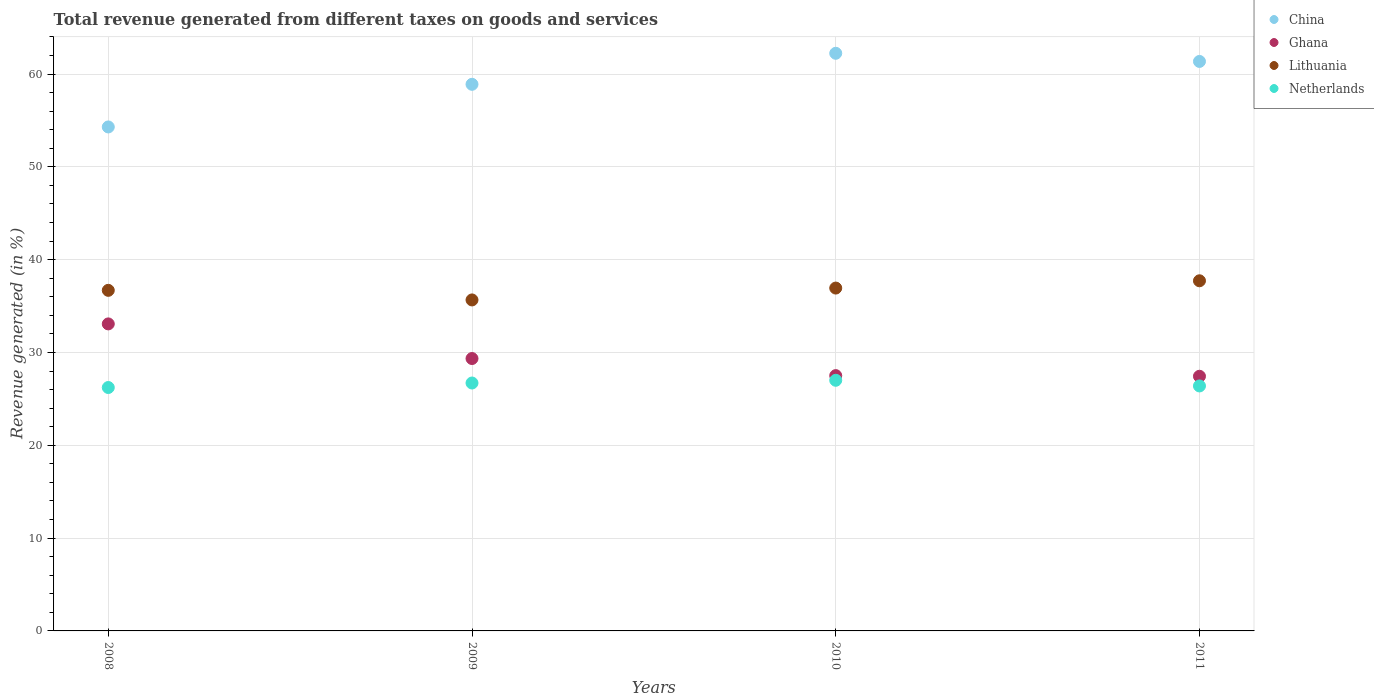How many different coloured dotlines are there?
Your answer should be very brief. 4. Is the number of dotlines equal to the number of legend labels?
Provide a short and direct response. Yes. What is the total revenue generated in China in 2008?
Ensure brevity in your answer.  54.3. Across all years, what is the maximum total revenue generated in Lithuania?
Your answer should be very brief. 37.72. Across all years, what is the minimum total revenue generated in Ghana?
Make the answer very short. 27.44. In which year was the total revenue generated in China minimum?
Make the answer very short. 2008. What is the total total revenue generated in Ghana in the graph?
Your response must be concise. 117.37. What is the difference between the total revenue generated in Netherlands in 2008 and that in 2011?
Your answer should be compact. -0.17. What is the difference between the total revenue generated in China in 2011 and the total revenue generated in Ghana in 2009?
Offer a very short reply. 32.01. What is the average total revenue generated in Netherlands per year?
Your answer should be compact. 26.58. In the year 2008, what is the difference between the total revenue generated in Netherlands and total revenue generated in China?
Your answer should be very brief. -28.07. What is the ratio of the total revenue generated in China in 2010 to that in 2011?
Provide a succinct answer. 1.01. Is the total revenue generated in Ghana in 2008 less than that in 2009?
Give a very brief answer. No. Is the difference between the total revenue generated in Netherlands in 2009 and 2011 greater than the difference between the total revenue generated in China in 2009 and 2011?
Offer a terse response. Yes. What is the difference between the highest and the second highest total revenue generated in Ghana?
Provide a short and direct response. 3.73. What is the difference between the highest and the lowest total revenue generated in Ghana?
Make the answer very short. 5.64. In how many years, is the total revenue generated in China greater than the average total revenue generated in China taken over all years?
Your answer should be very brief. 2. Is it the case that in every year, the sum of the total revenue generated in Lithuania and total revenue generated in Netherlands  is greater than the sum of total revenue generated in China and total revenue generated in Ghana?
Make the answer very short. No. Does the total revenue generated in Lithuania monotonically increase over the years?
Ensure brevity in your answer.  No. How many years are there in the graph?
Your answer should be very brief. 4. Does the graph contain any zero values?
Offer a terse response. No. How many legend labels are there?
Your response must be concise. 4. What is the title of the graph?
Provide a short and direct response. Total revenue generated from different taxes on goods and services. What is the label or title of the X-axis?
Provide a succinct answer. Years. What is the label or title of the Y-axis?
Your response must be concise. Revenue generated (in %). What is the Revenue generated (in %) of China in 2008?
Offer a terse response. 54.3. What is the Revenue generated (in %) of Ghana in 2008?
Ensure brevity in your answer.  33.08. What is the Revenue generated (in %) of Lithuania in 2008?
Your answer should be very brief. 36.69. What is the Revenue generated (in %) in Netherlands in 2008?
Your answer should be compact. 26.22. What is the Revenue generated (in %) in China in 2009?
Provide a short and direct response. 58.89. What is the Revenue generated (in %) in Ghana in 2009?
Your answer should be very brief. 29.35. What is the Revenue generated (in %) of Lithuania in 2009?
Make the answer very short. 35.66. What is the Revenue generated (in %) in Netherlands in 2009?
Provide a short and direct response. 26.71. What is the Revenue generated (in %) in China in 2010?
Your response must be concise. 62.23. What is the Revenue generated (in %) of Ghana in 2010?
Provide a short and direct response. 27.51. What is the Revenue generated (in %) of Lithuania in 2010?
Provide a short and direct response. 36.94. What is the Revenue generated (in %) in Netherlands in 2010?
Ensure brevity in your answer.  27. What is the Revenue generated (in %) in China in 2011?
Give a very brief answer. 61.36. What is the Revenue generated (in %) of Ghana in 2011?
Your answer should be compact. 27.44. What is the Revenue generated (in %) in Lithuania in 2011?
Your response must be concise. 37.72. What is the Revenue generated (in %) in Netherlands in 2011?
Give a very brief answer. 26.39. Across all years, what is the maximum Revenue generated (in %) of China?
Give a very brief answer. 62.23. Across all years, what is the maximum Revenue generated (in %) in Ghana?
Your response must be concise. 33.08. Across all years, what is the maximum Revenue generated (in %) of Lithuania?
Keep it short and to the point. 37.72. Across all years, what is the maximum Revenue generated (in %) in Netherlands?
Provide a succinct answer. 27. Across all years, what is the minimum Revenue generated (in %) in China?
Your answer should be compact. 54.3. Across all years, what is the minimum Revenue generated (in %) in Ghana?
Provide a short and direct response. 27.44. Across all years, what is the minimum Revenue generated (in %) in Lithuania?
Offer a very short reply. 35.66. Across all years, what is the minimum Revenue generated (in %) of Netherlands?
Offer a very short reply. 26.22. What is the total Revenue generated (in %) in China in the graph?
Give a very brief answer. 236.78. What is the total Revenue generated (in %) in Ghana in the graph?
Your answer should be compact. 117.37. What is the total Revenue generated (in %) in Lithuania in the graph?
Provide a short and direct response. 147.02. What is the total Revenue generated (in %) in Netherlands in the graph?
Your response must be concise. 106.33. What is the difference between the Revenue generated (in %) in China in 2008 and that in 2009?
Provide a short and direct response. -4.59. What is the difference between the Revenue generated (in %) in Ghana in 2008 and that in 2009?
Your response must be concise. 3.73. What is the difference between the Revenue generated (in %) in Lithuania in 2008 and that in 2009?
Ensure brevity in your answer.  1.03. What is the difference between the Revenue generated (in %) of Netherlands in 2008 and that in 2009?
Give a very brief answer. -0.49. What is the difference between the Revenue generated (in %) in China in 2008 and that in 2010?
Keep it short and to the point. -7.94. What is the difference between the Revenue generated (in %) in Ghana in 2008 and that in 2010?
Your response must be concise. 5.57. What is the difference between the Revenue generated (in %) of Lithuania in 2008 and that in 2010?
Your answer should be compact. -0.24. What is the difference between the Revenue generated (in %) in Netherlands in 2008 and that in 2010?
Your answer should be compact. -0.78. What is the difference between the Revenue generated (in %) of China in 2008 and that in 2011?
Offer a terse response. -7.06. What is the difference between the Revenue generated (in %) of Ghana in 2008 and that in 2011?
Provide a short and direct response. 5.64. What is the difference between the Revenue generated (in %) in Lithuania in 2008 and that in 2011?
Give a very brief answer. -1.03. What is the difference between the Revenue generated (in %) of Netherlands in 2008 and that in 2011?
Your answer should be compact. -0.17. What is the difference between the Revenue generated (in %) of China in 2009 and that in 2010?
Make the answer very short. -3.34. What is the difference between the Revenue generated (in %) of Ghana in 2009 and that in 2010?
Offer a terse response. 1.84. What is the difference between the Revenue generated (in %) of Lithuania in 2009 and that in 2010?
Give a very brief answer. -1.28. What is the difference between the Revenue generated (in %) of Netherlands in 2009 and that in 2010?
Ensure brevity in your answer.  -0.29. What is the difference between the Revenue generated (in %) in China in 2009 and that in 2011?
Your answer should be compact. -2.46. What is the difference between the Revenue generated (in %) of Ghana in 2009 and that in 2011?
Provide a succinct answer. 1.91. What is the difference between the Revenue generated (in %) in Lithuania in 2009 and that in 2011?
Your answer should be very brief. -2.06. What is the difference between the Revenue generated (in %) of Netherlands in 2009 and that in 2011?
Your answer should be very brief. 0.32. What is the difference between the Revenue generated (in %) in China in 2010 and that in 2011?
Your response must be concise. 0.88. What is the difference between the Revenue generated (in %) in Ghana in 2010 and that in 2011?
Offer a very short reply. 0.07. What is the difference between the Revenue generated (in %) of Lithuania in 2010 and that in 2011?
Your answer should be very brief. -0.78. What is the difference between the Revenue generated (in %) in Netherlands in 2010 and that in 2011?
Your response must be concise. 0.61. What is the difference between the Revenue generated (in %) of China in 2008 and the Revenue generated (in %) of Ghana in 2009?
Make the answer very short. 24.95. What is the difference between the Revenue generated (in %) in China in 2008 and the Revenue generated (in %) in Lithuania in 2009?
Give a very brief answer. 18.64. What is the difference between the Revenue generated (in %) of China in 2008 and the Revenue generated (in %) of Netherlands in 2009?
Offer a very short reply. 27.59. What is the difference between the Revenue generated (in %) of Ghana in 2008 and the Revenue generated (in %) of Lithuania in 2009?
Give a very brief answer. -2.58. What is the difference between the Revenue generated (in %) of Ghana in 2008 and the Revenue generated (in %) of Netherlands in 2009?
Your answer should be compact. 6.37. What is the difference between the Revenue generated (in %) in Lithuania in 2008 and the Revenue generated (in %) in Netherlands in 2009?
Offer a terse response. 9.98. What is the difference between the Revenue generated (in %) in China in 2008 and the Revenue generated (in %) in Ghana in 2010?
Offer a very short reply. 26.79. What is the difference between the Revenue generated (in %) in China in 2008 and the Revenue generated (in %) in Lithuania in 2010?
Your response must be concise. 17.36. What is the difference between the Revenue generated (in %) in China in 2008 and the Revenue generated (in %) in Netherlands in 2010?
Provide a succinct answer. 27.29. What is the difference between the Revenue generated (in %) in Ghana in 2008 and the Revenue generated (in %) in Lithuania in 2010?
Your answer should be compact. -3.86. What is the difference between the Revenue generated (in %) in Ghana in 2008 and the Revenue generated (in %) in Netherlands in 2010?
Ensure brevity in your answer.  6.07. What is the difference between the Revenue generated (in %) in Lithuania in 2008 and the Revenue generated (in %) in Netherlands in 2010?
Your response must be concise. 9.69. What is the difference between the Revenue generated (in %) in China in 2008 and the Revenue generated (in %) in Ghana in 2011?
Provide a short and direct response. 26.86. What is the difference between the Revenue generated (in %) of China in 2008 and the Revenue generated (in %) of Lithuania in 2011?
Offer a very short reply. 16.57. What is the difference between the Revenue generated (in %) in China in 2008 and the Revenue generated (in %) in Netherlands in 2011?
Your answer should be compact. 27.9. What is the difference between the Revenue generated (in %) in Ghana in 2008 and the Revenue generated (in %) in Lithuania in 2011?
Offer a very short reply. -4.65. What is the difference between the Revenue generated (in %) of Ghana in 2008 and the Revenue generated (in %) of Netherlands in 2011?
Offer a very short reply. 6.68. What is the difference between the Revenue generated (in %) in Lithuania in 2008 and the Revenue generated (in %) in Netherlands in 2011?
Your answer should be compact. 10.3. What is the difference between the Revenue generated (in %) of China in 2009 and the Revenue generated (in %) of Ghana in 2010?
Your answer should be very brief. 31.39. What is the difference between the Revenue generated (in %) of China in 2009 and the Revenue generated (in %) of Lithuania in 2010?
Give a very brief answer. 21.95. What is the difference between the Revenue generated (in %) of China in 2009 and the Revenue generated (in %) of Netherlands in 2010?
Offer a very short reply. 31.89. What is the difference between the Revenue generated (in %) of Ghana in 2009 and the Revenue generated (in %) of Lithuania in 2010?
Your answer should be very brief. -7.59. What is the difference between the Revenue generated (in %) of Ghana in 2009 and the Revenue generated (in %) of Netherlands in 2010?
Your answer should be compact. 2.34. What is the difference between the Revenue generated (in %) of Lithuania in 2009 and the Revenue generated (in %) of Netherlands in 2010?
Provide a succinct answer. 8.66. What is the difference between the Revenue generated (in %) in China in 2009 and the Revenue generated (in %) in Ghana in 2011?
Provide a succinct answer. 31.46. What is the difference between the Revenue generated (in %) of China in 2009 and the Revenue generated (in %) of Lithuania in 2011?
Your answer should be compact. 21.17. What is the difference between the Revenue generated (in %) of China in 2009 and the Revenue generated (in %) of Netherlands in 2011?
Offer a very short reply. 32.5. What is the difference between the Revenue generated (in %) of Ghana in 2009 and the Revenue generated (in %) of Lithuania in 2011?
Your answer should be compact. -8.38. What is the difference between the Revenue generated (in %) in Ghana in 2009 and the Revenue generated (in %) in Netherlands in 2011?
Keep it short and to the point. 2.95. What is the difference between the Revenue generated (in %) in Lithuania in 2009 and the Revenue generated (in %) in Netherlands in 2011?
Your response must be concise. 9.27. What is the difference between the Revenue generated (in %) in China in 2010 and the Revenue generated (in %) in Ghana in 2011?
Your answer should be very brief. 34.8. What is the difference between the Revenue generated (in %) of China in 2010 and the Revenue generated (in %) of Lithuania in 2011?
Provide a short and direct response. 24.51. What is the difference between the Revenue generated (in %) of China in 2010 and the Revenue generated (in %) of Netherlands in 2011?
Your answer should be very brief. 35.84. What is the difference between the Revenue generated (in %) of Ghana in 2010 and the Revenue generated (in %) of Lithuania in 2011?
Make the answer very short. -10.22. What is the difference between the Revenue generated (in %) of Ghana in 2010 and the Revenue generated (in %) of Netherlands in 2011?
Your response must be concise. 1.11. What is the difference between the Revenue generated (in %) of Lithuania in 2010 and the Revenue generated (in %) of Netherlands in 2011?
Give a very brief answer. 10.54. What is the average Revenue generated (in %) of China per year?
Ensure brevity in your answer.  59.2. What is the average Revenue generated (in %) in Ghana per year?
Offer a terse response. 29.34. What is the average Revenue generated (in %) in Lithuania per year?
Your response must be concise. 36.75. What is the average Revenue generated (in %) of Netherlands per year?
Ensure brevity in your answer.  26.58. In the year 2008, what is the difference between the Revenue generated (in %) of China and Revenue generated (in %) of Ghana?
Your answer should be compact. 21.22. In the year 2008, what is the difference between the Revenue generated (in %) of China and Revenue generated (in %) of Lithuania?
Offer a terse response. 17.6. In the year 2008, what is the difference between the Revenue generated (in %) in China and Revenue generated (in %) in Netherlands?
Offer a terse response. 28.07. In the year 2008, what is the difference between the Revenue generated (in %) of Ghana and Revenue generated (in %) of Lithuania?
Give a very brief answer. -3.62. In the year 2008, what is the difference between the Revenue generated (in %) of Ghana and Revenue generated (in %) of Netherlands?
Your response must be concise. 6.85. In the year 2008, what is the difference between the Revenue generated (in %) in Lithuania and Revenue generated (in %) in Netherlands?
Your answer should be compact. 10.47. In the year 2009, what is the difference between the Revenue generated (in %) of China and Revenue generated (in %) of Ghana?
Your answer should be very brief. 29.54. In the year 2009, what is the difference between the Revenue generated (in %) of China and Revenue generated (in %) of Lithuania?
Make the answer very short. 23.23. In the year 2009, what is the difference between the Revenue generated (in %) in China and Revenue generated (in %) in Netherlands?
Your answer should be compact. 32.18. In the year 2009, what is the difference between the Revenue generated (in %) in Ghana and Revenue generated (in %) in Lithuania?
Make the answer very short. -6.31. In the year 2009, what is the difference between the Revenue generated (in %) of Ghana and Revenue generated (in %) of Netherlands?
Provide a succinct answer. 2.64. In the year 2009, what is the difference between the Revenue generated (in %) in Lithuania and Revenue generated (in %) in Netherlands?
Make the answer very short. 8.95. In the year 2010, what is the difference between the Revenue generated (in %) in China and Revenue generated (in %) in Ghana?
Ensure brevity in your answer.  34.73. In the year 2010, what is the difference between the Revenue generated (in %) in China and Revenue generated (in %) in Lithuania?
Offer a very short reply. 25.3. In the year 2010, what is the difference between the Revenue generated (in %) of China and Revenue generated (in %) of Netherlands?
Your answer should be very brief. 35.23. In the year 2010, what is the difference between the Revenue generated (in %) of Ghana and Revenue generated (in %) of Lithuania?
Your answer should be compact. -9.43. In the year 2010, what is the difference between the Revenue generated (in %) in Ghana and Revenue generated (in %) in Netherlands?
Your response must be concise. 0.5. In the year 2010, what is the difference between the Revenue generated (in %) of Lithuania and Revenue generated (in %) of Netherlands?
Give a very brief answer. 9.94. In the year 2011, what is the difference between the Revenue generated (in %) of China and Revenue generated (in %) of Ghana?
Your answer should be compact. 33.92. In the year 2011, what is the difference between the Revenue generated (in %) in China and Revenue generated (in %) in Lithuania?
Make the answer very short. 23.63. In the year 2011, what is the difference between the Revenue generated (in %) in China and Revenue generated (in %) in Netherlands?
Ensure brevity in your answer.  34.96. In the year 2011, what is the difference between the Revenue generated (in %) in Ghana and Revenue generated (in %) in Lithuania?
Make the answer very short. -10.29. In the year 2011, what is the difference between the Revenue generated (in %) of Ghana and Revenue generated (in %) of Netherlands?
Offer a terse response. 1.04. In the year 2011, what is the difference between the Revenue generated (in %) in Lithuania and Revenue generated (in %) in Netherlands?
Ensure brevity in your answer.  11.33. What is the ratio of the Revenue generated (in %) in China in 2008 to that in 2009?
Provide a short and direct response. 0.92. What is the ratio of the Revenue generated (in %) of Ghana in 2008 to that in 2009?
Provide a succinct answer. 1.13. What is the ratio of the Revenue generated (in %) in Netherlands in 2008 to that in 2009?
Make the answer very short. 0.98. What is the ratio of the Revenue generated (in %) in China in 2008 to that in 2010?
Offer a very short reply. 0.87. What is the ratio of the Revenue generated (in %) in Ghana in 2008 to that in 2010?
Offer a very short reply. 1.2. What is the ratio of the Revenue generated (in %) of Netherlands in 2008 to that in 2010?
Offer a terse response. 0.97. What is the ratio of the Revenue generated (in %) of China in 2008 to that in 2011?
Keep it short and to the point. 0.89. What is the ratio of the Revenue generated (in %) in Ghana in 2008 to that in 2011?
Your response must be concise. 1.21. What is the ratio of the Revenue generated (in %) in Lithuania in 2008 to that in 2011?
Offer a terse response. 0.97. What is the ratio of the Revenue generated (in %) of Netherlands in 2008 to that in 2011?
Offer a very short reply. 0.99. What is the ratio of the Revenue generated (in %) in China in 2009 to that in 2010?
Your answer should be compact. 0.95. What is the ratio of the Revenue generated (in %) in Ghana in 2009 to that in 2010?
Your answer should be compact. 1.07. What is the ratio of the Revenue generated (in %) of Lithuania in 2009 to that in 2010?
Your answer should be compact. 0.97. What is the ratio of the Revenue generated (in %) of Netherlands in 2009 to that in 2010?
Provide a short and direct response. 0.99. What is the ratio of the Revenue generated (in %) of China in 2009 to that in 2011?
Your answer should be compact. 0.96. What is the ratio of the Revenue generated (in %) of Ghana in 2009 to that in 2011?
Provide a short and direct response. 1.07. What is the ratio of the Revenue generated (in %) of Lithuania in 2009 to that in 2011?
Make the answer very short. 0.95. What is the ratio of the Revenue generated (in %) of China in 2010 to that in 2011?
Your answer should be compact. 1.01. What is the ratio of the Revenue generated (in %) of Ghana in 2010 to that in 2011?
Provide a short and direct response. 1. What is the ratio of the Revenue generated (in %) in Lithuania in 2010 to that in 2011?
Provide a succinct answer. 0.98. What is the ratio of the Revenue generated (in %) of Netherlands in 2010 to that in 2011?
Provide a succinct answer. 1.02. What is the difference between the highest and the second highest Revenue generated (in %) of China?
Make the answer very short. 0.88. What is the difference between the highest and the second highest Revenue generated (in %) of Ghana?
Offer a terse response. 3.73. What is the difference between the highest and the second highest Revenue generated (in %) in Lithuania?
Offer a terse response. 0.78. What is the difference between the highest and the second highest Revenue generated (in %) in Netherlands?
Provide a succinct answer. 0.29. What is the difference between the highest and the lowest Revenue generated (in %) of China?
Make the answer very short. 7.94. What is the difference between the highest and the lowest Revenue generated (in %) of Ghana?
Make the answer very short. 5.64. What is the difference between the highest and the lowest Revenue generated (in %) in Lithuania?
Provide a succinct answer. 2.06. What is the difference between the highest and the lowest Revenue generated (in %) in Netherlands?
Provide a succinct answer. 0.78. 